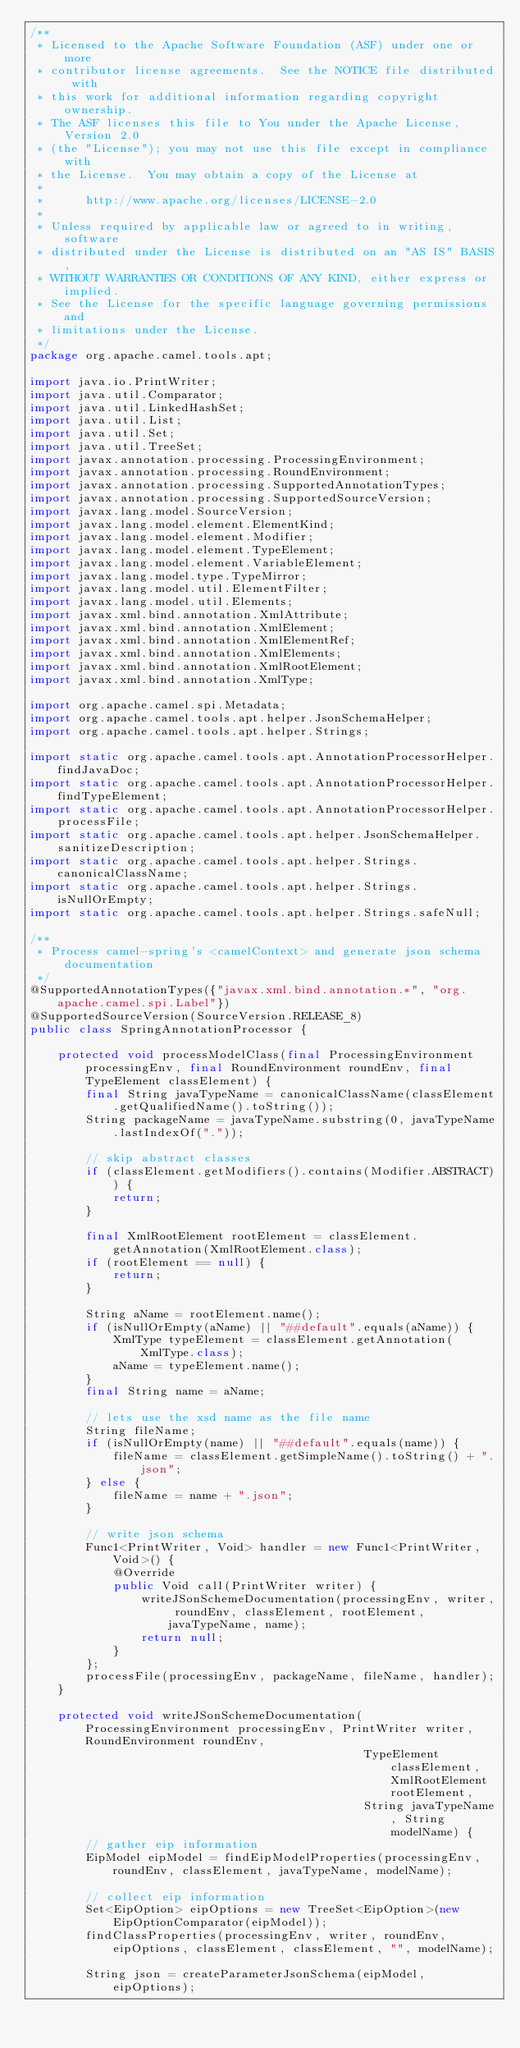<code> <loc_0><loc_0><loc_500><loc_500><_Java_>/**
 * Licensed to the Apache Software Foundation (ASF) under one or more
 * contributor license agreements.  See the NOTICE file distributed with
 * this work for additional information regarding copyright ownership.
 * The ASF licenses this file to You under the Apache License, Version 2.0
 * (the "License"); you may not use this file except in compliance with
 * the License.  You may obtain a copy of the License at
 *
 *      http://www.apache.org/licenses/LICENSE-2.0
 *
 * Unless required by applicable law or agreed to in writing, software
 * distributed under the License is distributed on an "AS IS" BASIS,
 * WITHOUT WARRANTIES OR CONDITIONS OF ANY KIND, either express or implied.
 * See the License for the specific language governing permissions and
 * limitations under the License.
 */
package org.apache.camel.tools.apt;

import java.io.PrintWriter;
import java.util.Comparator;
import java.util.LinkedHashSet;
import java.util.List;
import java.util.Set;
import java.util.TreeSet;
import javax.annotation.processing.ProcessingEnvironment;
import javax.annotation.processing.RoundEnvironment;
import javax.annotation.processing.SupportedAnnotationTypes;
import javax.annotation.processing.SupportedSourceVersion;
import javax.lang.model.SourceVersion;
import javax.lang.model.element.ElementKind;
import javax.lang.model.element.Modifier;
import javax.lang.model.element.TypeElement;
import javax.lang.model.element.VariableElement;
import javax.lang.model.type.TypeMirror;
import javax.lang.model.util.ElementFilter;
import javax.lang.model.util.Elements;
import javax.xml.bind.annotation.XmlAttribute;
import javax.xml.bind.annotation.XmlElement;
import javax.xml.bind.annotation.XmlElementRef;
import javax.xml.bind.annotation.XmlElements;
import javax.xml.bind.annotation.XmlRootElement;
import javax.xml.bind.annotation.XmlType;

import org.apache.camel.spi.Metadata;
import org.apache.camel.tools.apt.helper.JsonSchemaHelper;
import org.apache.camel.tools.apt.helper.Strings;

import static org.apache.camel.tools.apt.AnnotationProcessorHelper.findJavaDoc;
import static org.apache.camel.tools.apt.AnnotationProcessorHelper.findTypeElement;
import static org.apache.camel.tools.apt.AnnotationProcessorHelper.processFile;
import static org.apache.camel.tools.apt.helper.JsonSchemaHelper.sanitizeDescription;
import static org.apache.camel.tools.apt.helper.Strings.canonicalClassName;
import static org.apache.camel.tools.apt.helper.Strings.isNullOrEmpty;
import static org.apache.camel.tools.apt.helper.Strings.safeNull;

/**
 * Process camel-spring's <camelContext> and generate json schema documentation
 */
@SupportedAnnotationTypes({"javax.xml.bind.annotation.*", "org.apache.camel.spi.Label"})
@SupportedSourceVersion(SourceVersion.RELEASE_8)
public class SpringAnnotationProcessor {

    protected void processModelClass(final ProcessingEnvironment processingEnv, final RoundEnvironment roundEnv, final TypeElement classElement) {
        final String javaTypeName = canonicalClassName(classElement.getQualifiedName().toString());
        String packageName = javaTypeName.substring(0, javaTypeName.lastIndexOf("."));

        // skip abstract classes
        if (classElement.getModifiers().contains(Modifier.ABSTRACT)) {
            return;
        }

        final XmlRootElement rootElement = classElement.getAnnotation(XmlRootElement.class);
        if (rootElement == null) {
            return;
        }

        String aName = rootElement.name();
        if (isNullOrEmpty(aName) || "##default".equals(aName)) {
            XmlType typeElement = classElement.getAnnotation(XmlType.class);
            aName = typeElement.name();
        }
        final String name = aName;

        // lets use the xsd name as the file name
        String fileName;
        if (isNullOrEmpty(name) || "##default".equals(name)) {
            fileName = classElement.getSimpleName().toString() + ".json";
        } else {
            fileName = name + ".json";
        }

        // write json schema
        Func1<PrintWriter, Void> handler = new Func1<PrintWriter, Void>() {
            @Override
            public Void call(PrintWriter writer) {
                writeJSonSchemeDocumentation(processingEnv, writer, roundEnv, classElement, rootElement, javaTypeName, name);
                return null;
            }
        };
        processFile(processingEnv, packageName, fileName, handler);
    }

    protected void writeJSonSchemeDocumentation(ProcessingEnvironment processingEnv, PrintWriter writer, RoundEnvironment roundEnv,
                                                TypeElement classElement, XmlRootElement rootElement,
                                                String javaTypeName, String modelName) {
        // gather eip information
        EipModel eipModel = findEipModelProperties(processingEnv, roundEnv, classElement, javaTypeName, modelName);

        // collect eip information
        Set<EipOption> eipOptions = new TreeSet<EipOption>(new EipOptionComparator(eipModel));
        findClassProperties(processingEnv, writer, roundEnv, eipOptions, classElement, classElement, "", modelName);

        String json = createParameterJsonSchema(eipModel, eipOptions);</code> 